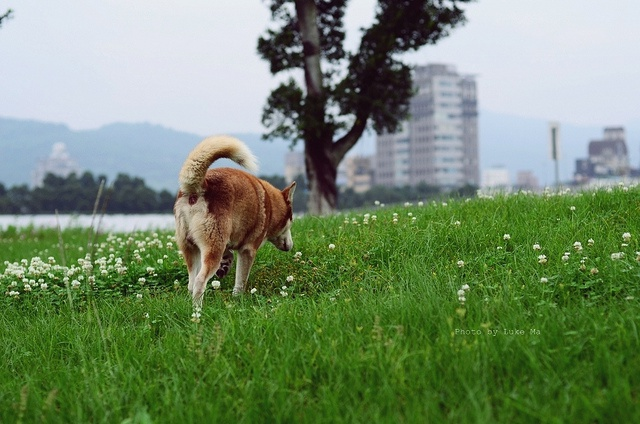Describe the objects in this image and their specific colors. I can see a dog in lightgray, maroon, black, and gray tones in this image. 